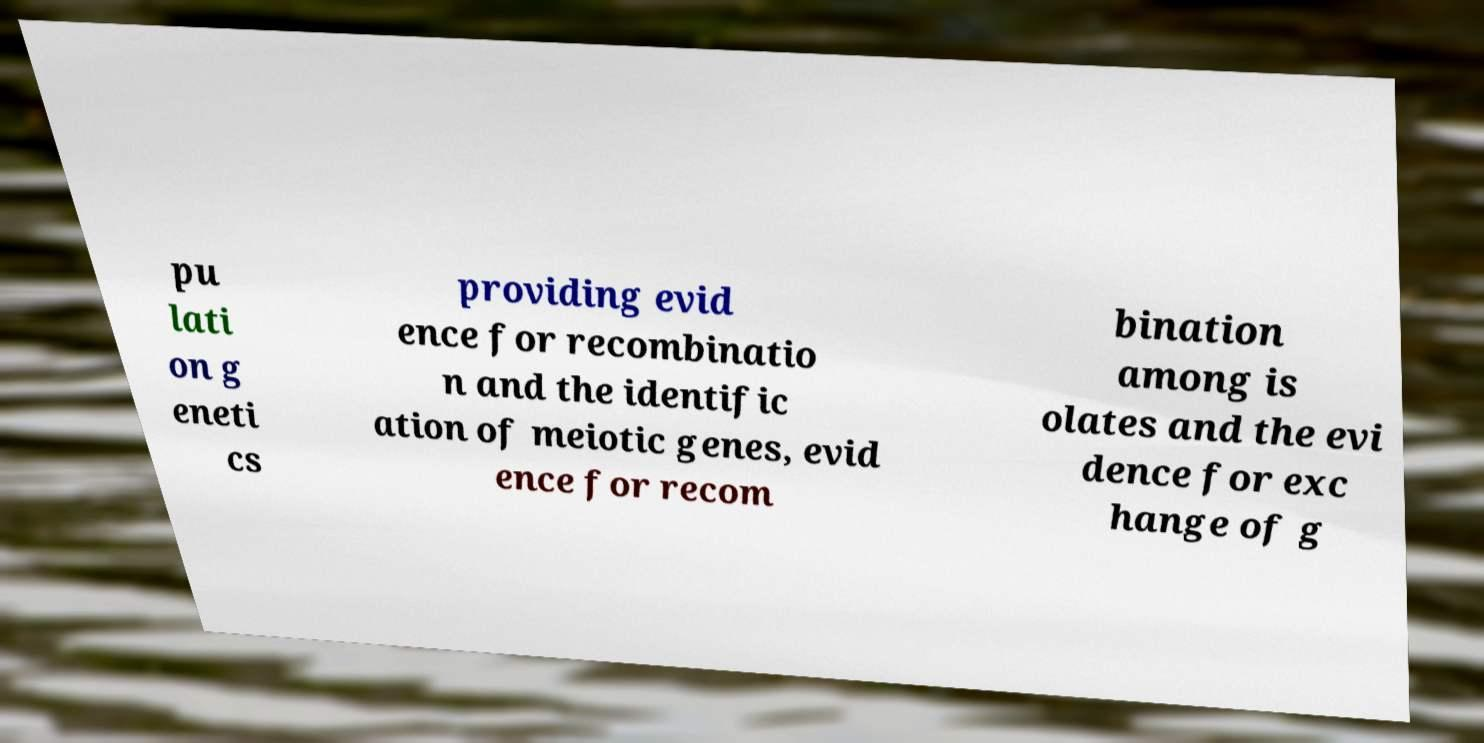Please read and relay the text visible in this image. What does it say? pu lati on g eneti cs providing evid ence for recombinatio n and the identific ation of meiotic genes, evid ence for recom bination among is olates and the evi dence for exc hange of g 